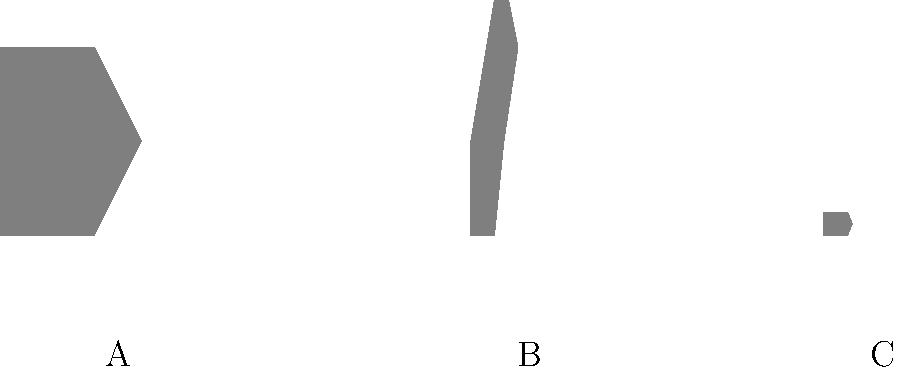Which of the animal silhouettes (A, B, or C) represents the largest animal in real life? To answer this question, we need to analyze the silhouettes and identify the animals they represent:

1. Silhouette A: This shape has a large, rounded body with a trunk-like protrusion. It represents an elephant.

2. Silhouette B: This shape has a long neck and legs, characteristic of a giraffe.

3. Silhouette C: This small, compact shape with a pointed snout likely represents a mouse.

Now, let's compare the sizes of these animals in real life:

1. Elephants are among the largest land animals, typically weighing 2,700-6,000 kg and standing 2.5-3.3 meters tall at the shoulder.

2. Giraffes are tall but not as massive as elephants. They usually weigh 800-1,900 kg and can reach heights of 4.3-5.7 meters.

3. Mice are very small, weighing only 10-25 grams and measuring about 7-10 cm in body length.

Comparing these animals, we can conclude that the elephant (silhouette A) is the largest animal in real life.
Answer: A 